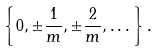Convert formula to latex. <formula><loc_0><loc_0><loc_500><loc_500>\left \{ 0 , \pm \frac { 1 } { m } , \pm \frac { 2 } { m } , \dots \right \} .</formula> 